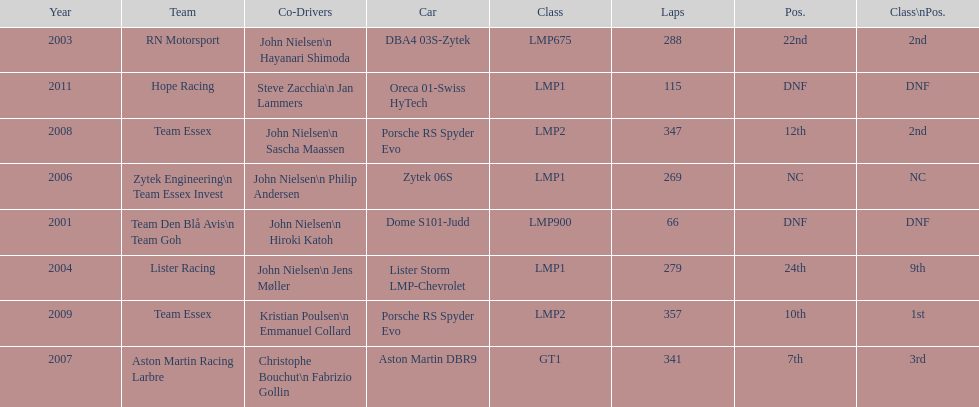In 2008 and what other year was casper elgaard on team essex for the 24 hours of le mans? 2009. 